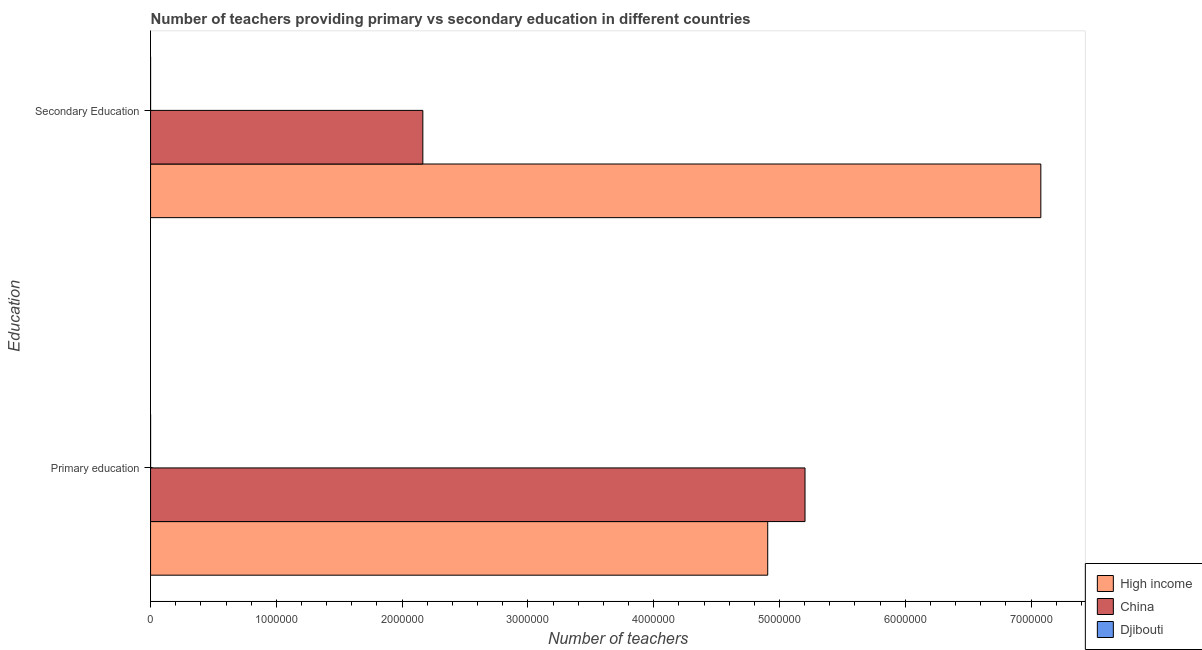How many different coloured bars are there?
Make the answer very short. 3. How many bars are there on the 2nd tick from the top?
Provide a succinct answer. 3. What is the label of the 1st group of bars from the top?
Give a very brief answer. Secondary Education. What is the number of primary teachers in High income?
Provide a succinct answer. 4.91e+06. Across all countries, what is the maximum number of secondary teachers?
Offer a very short reply. 7.08e+06. Across all countries, what is the minimum number of secondary teachers?
Offer a very short reply. 148. In which country was the number of secondary teachers maximum?
Keep it short and to the point. High income. In which country was the number of secondary teachers minimum?
Keep it short and to the point. Djibouti. What is the total number of primary teachers in the graph?
Provide a short and direct response. 1.01e+07. What is the difference between the number of secondary teachers in China and that in High income?
Keep it short and to the point. -4.91e+06. What is the difference between the number of primary teachers in High income and the number of secondary teachers in China?
Provide a short and direct response. 2.74e+06. What is the average number of secondary teachers per country?
Give a very brief answer. 3.08e+06. What is the difference between the number of primary teachers and number of secondary teachers in High income?
Give a very brief answer. -2.17e+06. In how many countries, is the number of secondary teachers greater than 1800000 ?
Your answer should be compact. 2. What is the ratio of the number of secondary teachers in High income to that in China?
Make the answer very short. 3.27. Is the number of secondary teachers in China less than that in Djibouti?
Ensure brevity in your answer.  No. How many bars are there?
Your answer should be very brief. 6. Are all the bars in the graph horizontal?
Give a very brief answer. Yes. What is the difference between two consecutive major ticks on the X-axis?
Your answer should be compact. 1.00e+06. Does the graph contain any zero values?
Your answer should be very brief. No. Does the graph contain grids?
Offer a very short reply. No. Where does the legend appear in the graph?
Ensure brevity in your answer.  Bottom right. What is the title of the graph?
Offer a very short reply. Number of teachers providing primary vs secondary education in different countries. What is the label or title of the X-axis?
Make the answer very short. Number of teachers. What is the label or title of the Y-axis?
Give a very brief answer. Education. What is the Number of teachers in High income in Primary education?
Your response must be concise. 4.91e+06. What is the Number of teachers in China in Primary education?
Offer a terse response. 5.20e+06. What is the Number of teachers in Djibouti in Primary education?
Offer a terse response. 268. What is the Number of teachers of High income in Secondary Education?
Provide a short and direct response. 7.08e+06. What is the Number of teachers of China in Secondary Education?
Provide a short and direct response. 2.16e+06. What is the Number of teachers in Djibouti in Secondary Education?
Provide a short and direct response. 148. Across all Education, what is the maximum Number of teachers of High income?
Provide a succinct answer. 7.08e+06. Across all Education, what is the maximum Number of teachers of China?
Give a very brief answer. 5.20e+06. Across all Education, what is the maximum Number of teachers in Djibouti?
Give a very brief answer. 268. Across all Education, what is the minimum Number of teachers in High income?
Keep it short and to the point. 4.91e+06. Across all Education, what is the minimum Number of teachers in China?
Give a very brief answer. 2.16e+06. Across all Education, what is the minimum Number of teachers in Djibouti?
Offer a terse response. 148. What is the total Number of teachers in High income in the graph?
Your answer should be compact. 1.20e+07. What is the total Number of teachers in China in the graph?
Make the answer very short. 7.37e+06. What is the total Number of teachers in Djibouti in the graph?
Ensure brevity in your answer.  416. What is the difference between the Number of teachers in High income in Primary education and that in Secondary Education?
Provide a succinct answer. -2.17e+06. What is the difference between the Number of teachers of China in Primary education and that in Secondary Education?
Your answer should be very brief. 3.04e+06. What is the difference between the Number of teachers in Djibouti in Primary education and that in Secondary Education?
Keep it short and to the point. 120. What is the difference between the Number of teachers in High income in Primary education and the Number of teachers in China in Secondary Education?
Ensure brevity in your answer.  2.74e+06. What is the difference between the Number of teachers in High income in Primary education and the Number of teachers in Djibouti in Secondary Education?
Your answer should be compact. 4.91e+06. What is the difference between the Number of teachers in China in Primary education and the Number of teachers in Djibouti in Secondary Education?
Offer a very short reply. 5.20e+06. What is the average Number of teachers of High income per Education?
Provide a succinct answer. 5.99e+06. What is the average Number of teachers of China per Education?
Offer a very short reply. 3.68e+06. What is the average Number of teachers of Djibouti per Education?
Keep it short and to the point. 208. What is the difference between the Number of teachers of High income and Number of teachers of China in Primary education?
Provide a short and direct response. -2.97e+05. What is the difference between the Number of teachers of High income and Number of teachers of Djibouti in Primary education?
Provide a succinct answer. 4.91e+06. What is the difference between the Number of teachers of China and Number of teachers of Djibouti in Primary education?
Keep it short and to the point. 5.20e+06. What is the difference between the Number of teachers of High income and Number of teachers of China in Secondary Education?
Offer a very short reply. 4.91e+06. What is the difference between the Number of teachers in High income and Number of teachers in Djibouti in Secondary Education?
Your answer should be compact. 7.08e+06. What is the difference between the Number of teachers of China and Number of teachers of Djibouti in Secondary Education?
Ensure brevity in your answer.  2.16e+06. What is the ratio of the Number of teachers in High income in Primary education to that in Secondary Education?
Keep it short and to the point. 0.69. What is the ratio of the Number of teachers of China in Primary education to that in Secondary Education?
Make the answer very short. 2.4. What is the ratio of the Number of teachers of Djibouti in Primary education to that in Secondary Education?
Your answer should be very brief. 1.81. What is the difference between the highest and the second highest Number of teachers in High income?
Make the answer very short. 2.17e+06. What is the difference between the highest and the second highest Number of teachers in China?
Keep it short and to the point. 3.04e+06. What is the difference between the highest and the second highest Number of teachers of Djibouti?
Give a very brief answer. 120. What is the difference between the highest and the lowest Number of teachers in High income?
Provide a succinct answer. 2.17e+06. What is the difference between the highest and the lowest Number of teachers of China?
Your answer should be very brief. 3.04e+06. What is the difference between the highest and the lowest Number of teachers in Djibouti?
Offer a very short reply. 120. 